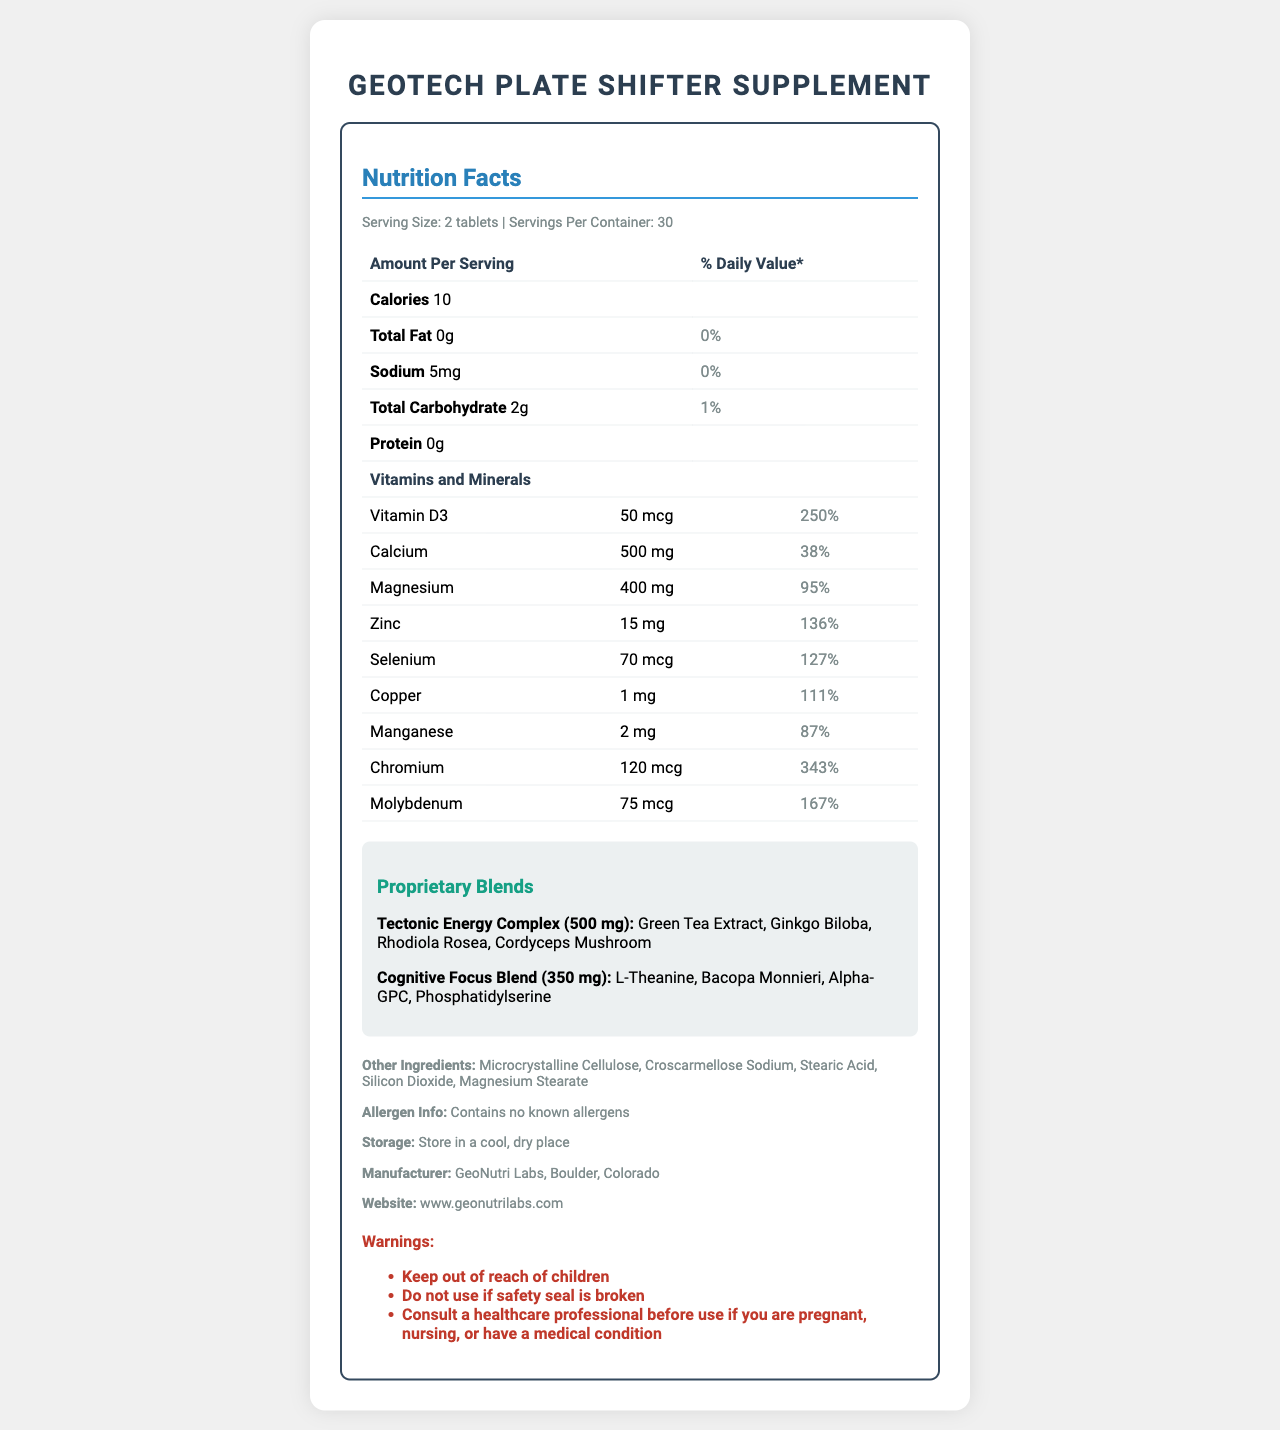what is the serving size? The document specifies the serving size as "2 tablets" in the serving information section.
Answer: 2 tablets how many servings per container? The serving information mentions that there are 30 servings per container.
Answer: 30 how many calories are in one serving? The first row under the Nutrition Facts section states that the amount per serving for calories is 10.
Answer: 10 how much Vitamin D3 is in one serving? Under the Vitamins and Minerals section, it lists Vitamin D3 as 50 mcg per serving.
Answer: 50 mcg what is the daily value percentage of Zinc? The Vitamins and Minerals section specifies that Zinc is 15 mg per serving, which corresponds to 136% of the daily value.
Answer: 136% what ingredients are in the Tectonic Energy Complex? The Proprietary Blends section lists the ingredients in the Tectonic Energy Complex as Green Tea Extract, Ginkgo Biloba, Rhodiola Rosea, Cordyceps Mushroom.
Answer: Green Tea Extract, Ginkgo Biloba, Rhodiola Rosea, Cordyceps Mushroom what is the total amount of the Cognitive Focus Blend? The Proprietary Blends section specifies that the amount of the Cognitive Focus Blend is 350 mg.
Answer: 350 mg who is the manufacturer of this supplement? The Other Info section lists the manufacturer as GeoNutri Labs, Boulder, Colorado.
Answer: GeoNutri Labs, Boulder, Colorado what are the warnings associated with this supplement? The Warnings section lists these three warnings: Keep out of reach of children, Do not use if safety seal is broken, Consult a healthcare professional before use if you are pregnant, nursing, or have a medical condition.
Answer: Keep out of reach of children, Do not use if safety seal is broken, Consult a healthcare professional before use if you are pregnant, nursing, or have a medical condition what is the website for more information? The website for more information is provided as www.geonutrilabs.com under the Other Info section.
Answer: www.geonutrilabs.com what is the sodium content per serving? Under the Nutrition Facts, it specifies that sodium per serving is 5 mg.
Answer: 5 mg how many mg of magnesium are in each serving? A. 300 mg B. 350 mg C. 400 mg D. 450 mg The Vitamins and Minerals section lists Magnesium as 400 mg per serving.
Answer: C. 400 mg what is the correct percentage of daily value for Chromium? A. 100% B. 250% C. 300% D. 343% The Vitamins and Minerals section specifies that Chromium has a daily value percentage of 343%.
Answer: D. 343% does this product contain any known allergens? The Allergen Info section states "Contains no known allergens."
Answer: No describe the main idea of the document This Nutrition Facts Label provides all necessary information about the GeoTech Plate Shifter Supplement, including dosage, calories, nutrients, proprietary blends, additional ingredients, warnings, and manufacturer information to help users understand the product's content and safe usage.
Answer: The document is a comprehensive Nutrition Facts Label for the GeoTech Plate Shifter Supplement, detailing serving sizes, nutritional values of vitamins and minerals, proprietary blends, other ingredients, allergen information, warnings, storage instructions, manufacturer details, and website for further information. how many tablets should be taken daily? The document specifies the serving size as "2 tablets" but does not clearly indicate whether this is the daily recommended dose.
Answer: Cannot be determined what percentage of daily value is provided by Manganese? The Vitamins and Minerals section lists Manganese as 87% of the daily value per serving.
Answer: 87% how much calcium does one serving provide? The Vitamins and Minerals section specifies that each serving contains 500 mg of Calcium.
Answer: 500 mg which ingredients help with cognitive focus? The Proprietary Blends section lists the ingredients of the Cognitive Focus Blend as L-Theanine, Bacopa Monnieri, Alpha-GPC, Phosphatidylserine.
Answer: L-Theanine, Bacopa Monnieri, Alpha-GPC, Phosphatidylserine 